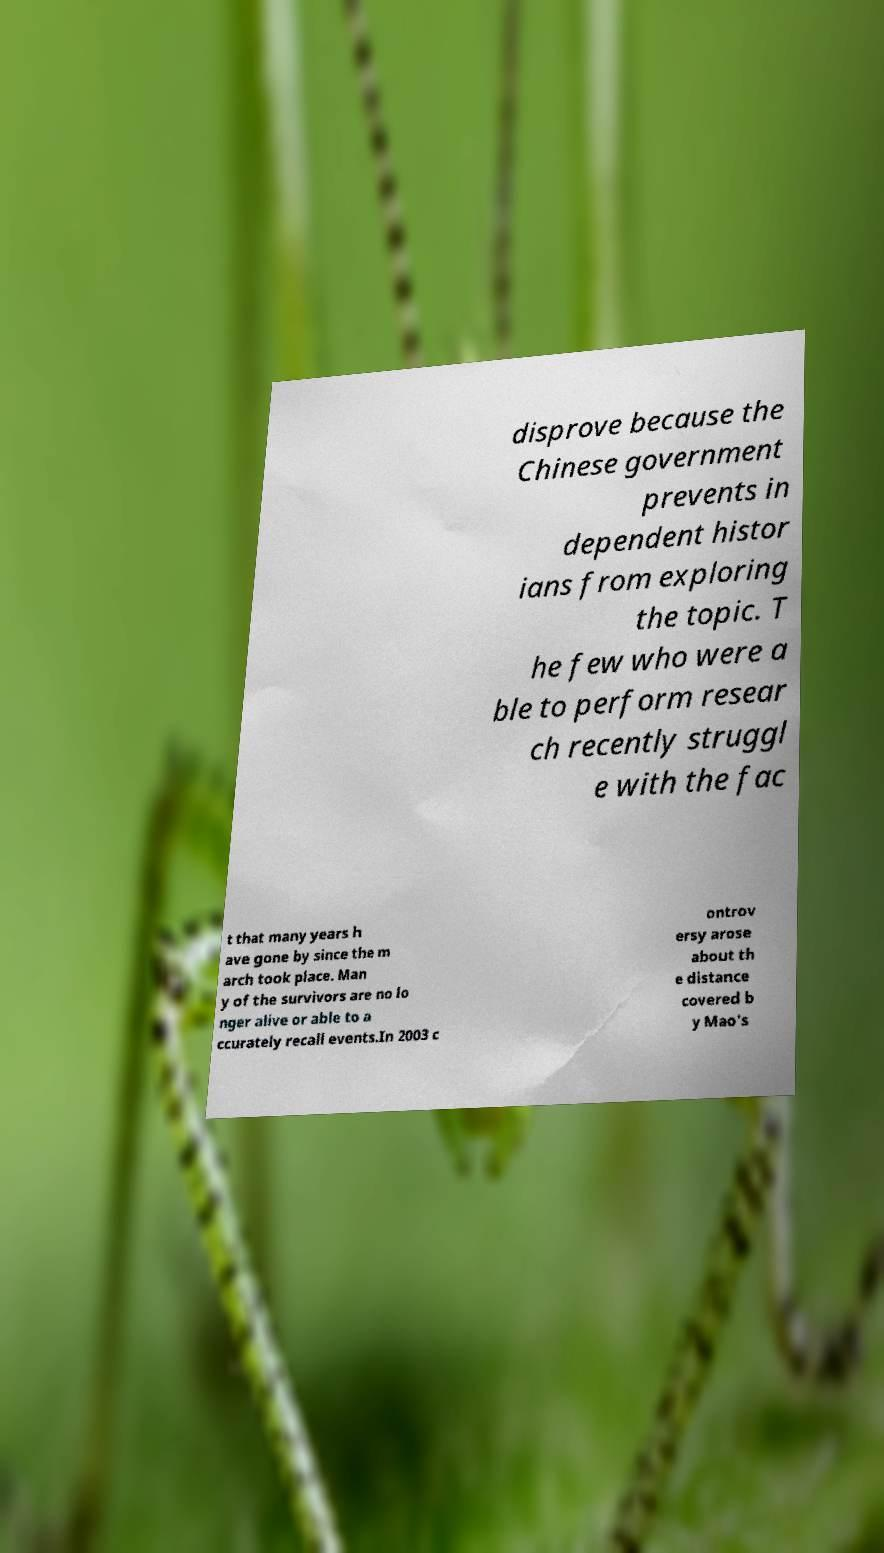Can you read and provide the text displayed in the image?This photo seems to have some interesting text. Can you extract and type it out for me? disprove because the Chinese government prevents in dependent histor ians from exploring the topic. T he few who were a ble to perform resear ch recently struggl e with the fac t that many years h ave gone by since the m arch took place. Man y of the survivors are no lo nger alive or able to a ccurately recall events.In 2003 c ontrov ersy arose about th e distance covered b y Mao's 